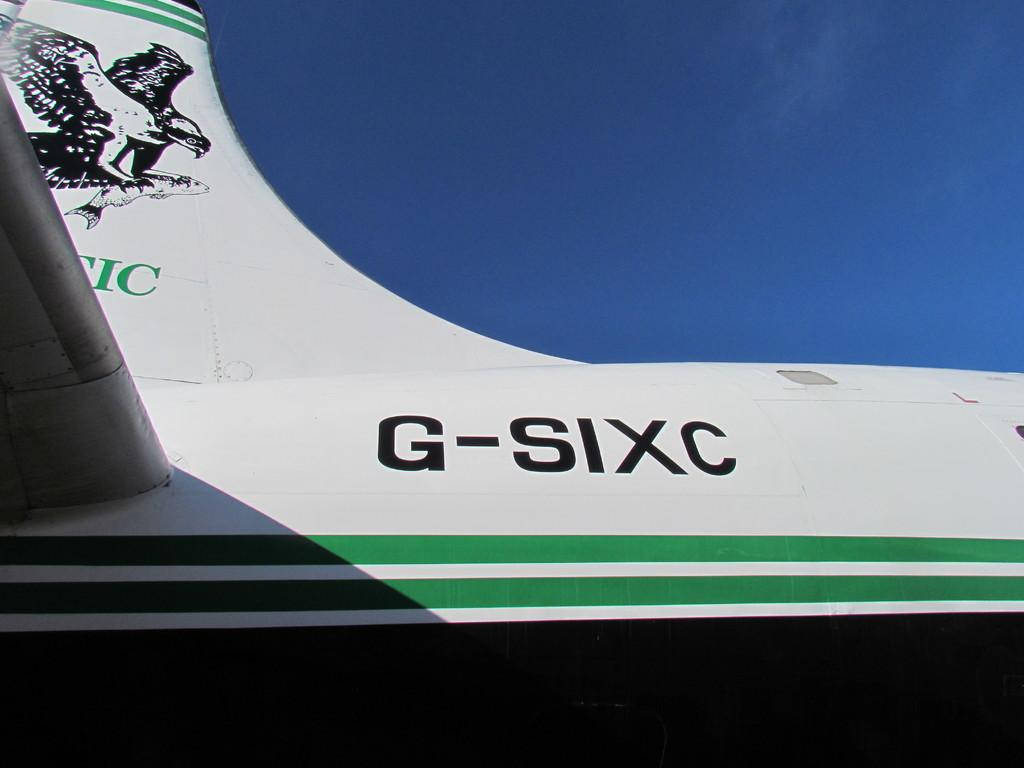<image>
Render a clear and concise summary of the photo. Eagle is on the wing of the G-SIXC 